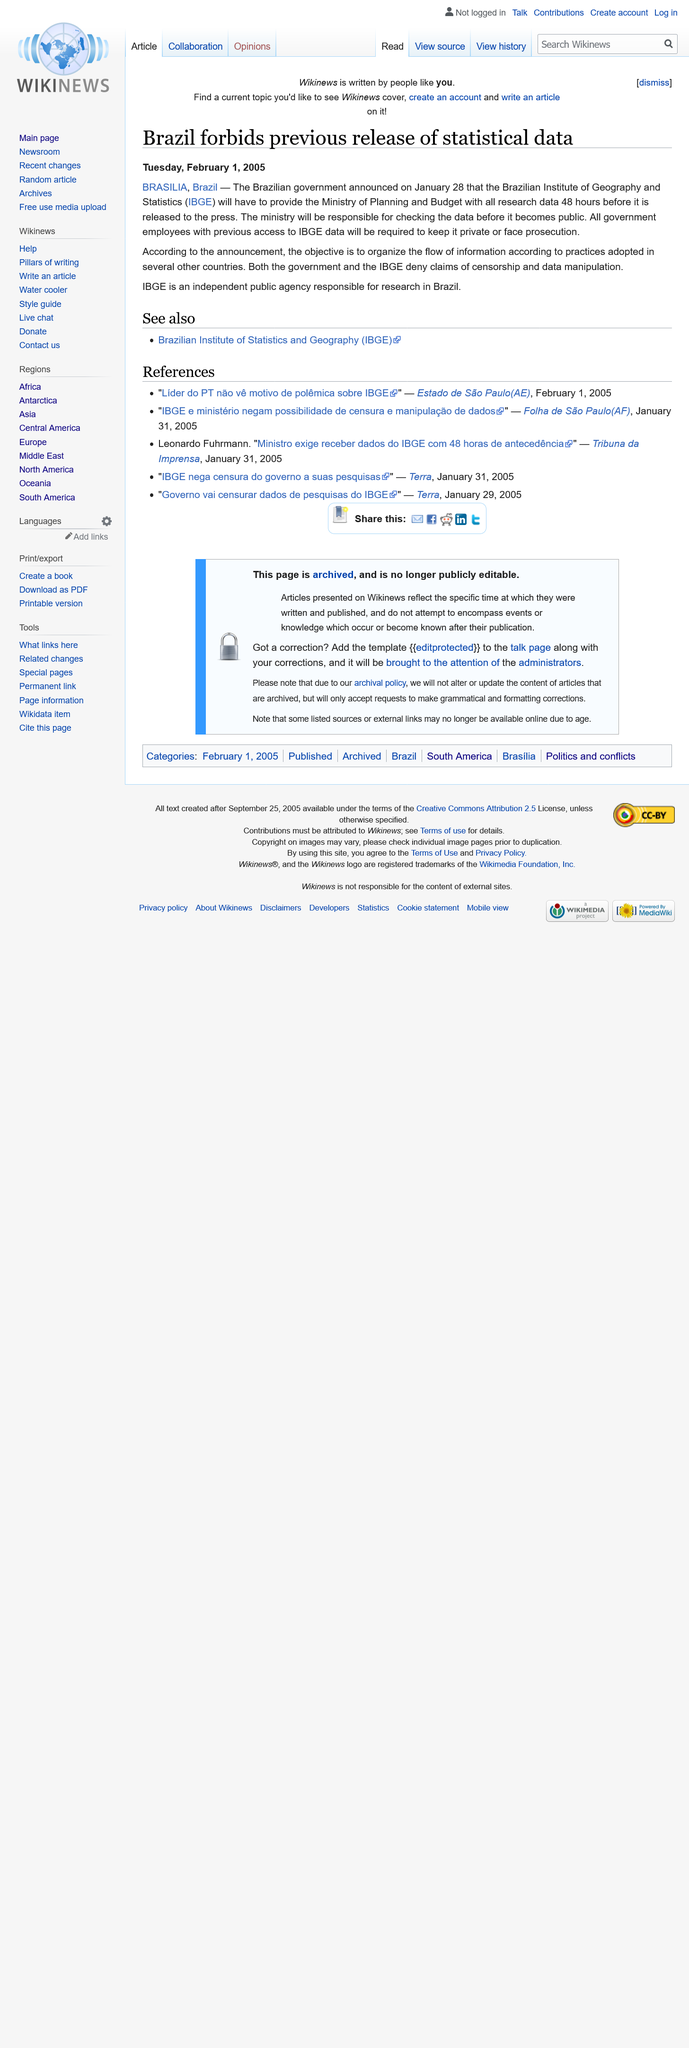Point out several critical features in this image. Brazil prohibits the release of statistical data in certain situations. It shall be the responsibility of the Ministry to review and verify all data prior to its public release. The government and the IBGE have denied allegations of censorship and data manipulation. 